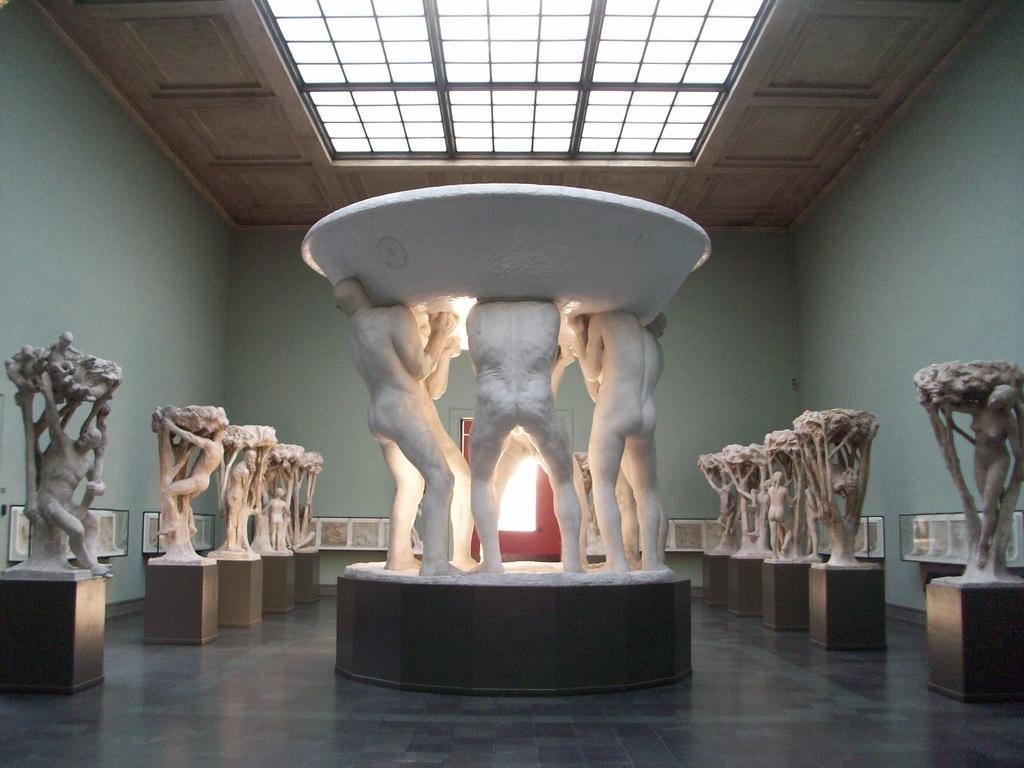Can you describe this image briefly? This picture is clicked inside the room. On both the sides we can see the sculptures of persons and the sculptures of some objects. In the center we can see the sculptures of persons standing and lifting some object. In the background we can see the wall and some other objects. At the top there is a roof. 